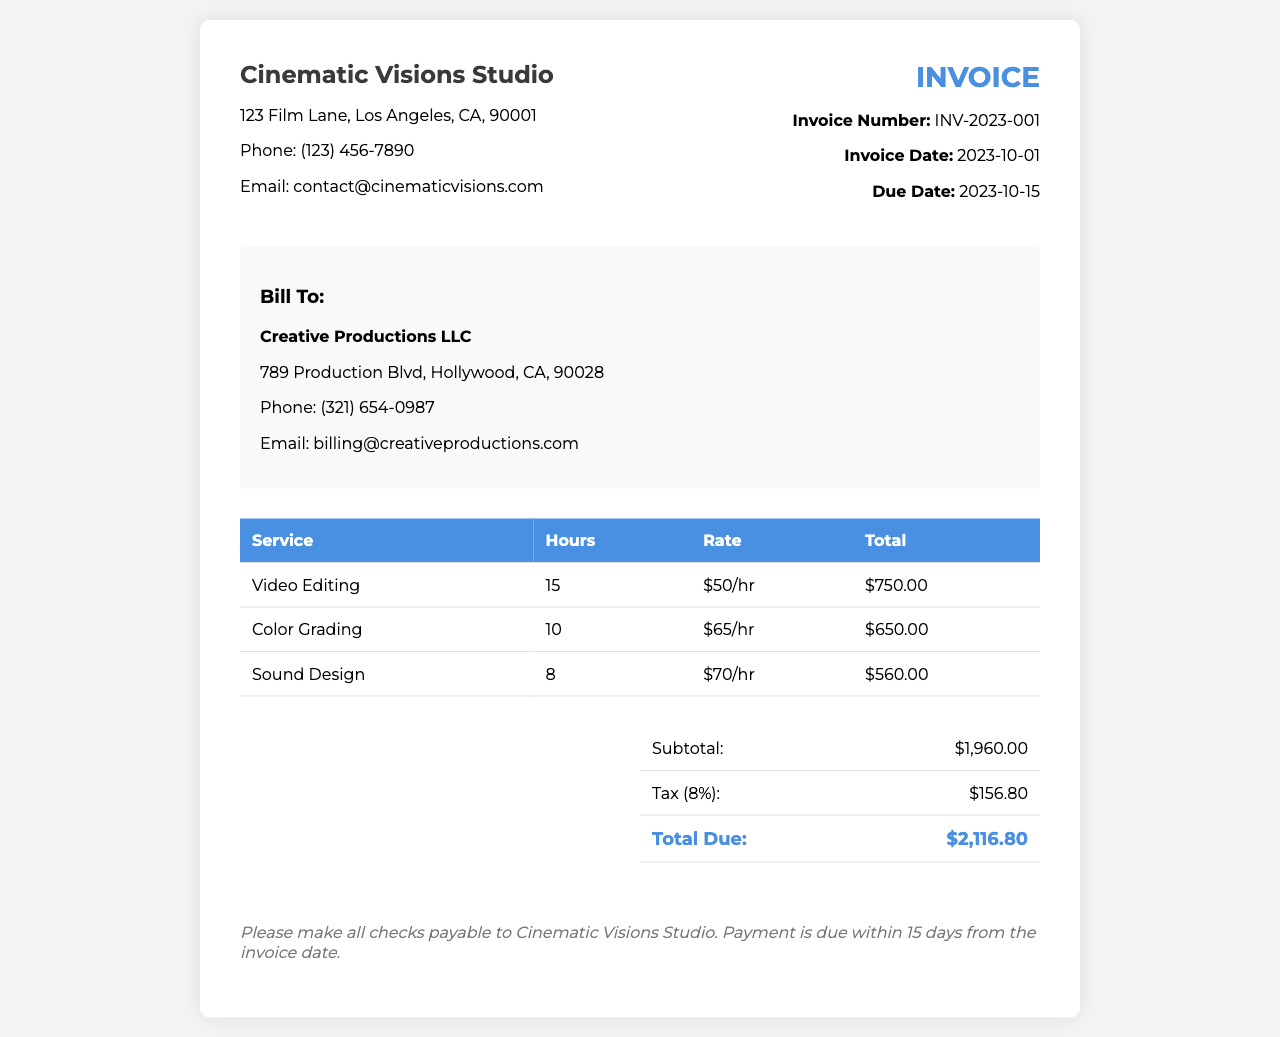What is the total due amount? The total due amount is calculated by adding the subtotal and tax. The subtotal is $1,960.00 and the tax is $156.80, resulting in a total of $2,116.80.
Answer: $2,116.80 What is the invoice date? The date mentioned in the invoice details indicates when the invoice was created, which is 2023-10-01.
Answer: 2023-10-01 Who is the client? The invoice states the client information as Creative Productions LLC, which is the billed entity.
Answer: Creative Productions LLC How much was charged for sound design? The total specific to sound design is shown in the invoice table, which lists the total for that service.
Answer: $560.00 What is the tax rate applied? The tax rate applied is given as a percentage in the summary section of the invoice, which is 8%.
Answer: 8% How many hours were spent on color grading? The hours dedicated to color grading are specified in the invoice, showing a clear breakdown for that service.
Answer: 10 What is the rate for video editing? The rate for video editing is detailed in the invoice under the respective service.
Answer: $50/hr What is the due date for payment? The due date is noted in the invoice details, indicating when payment should be made.
Answer: 2023-10-15 